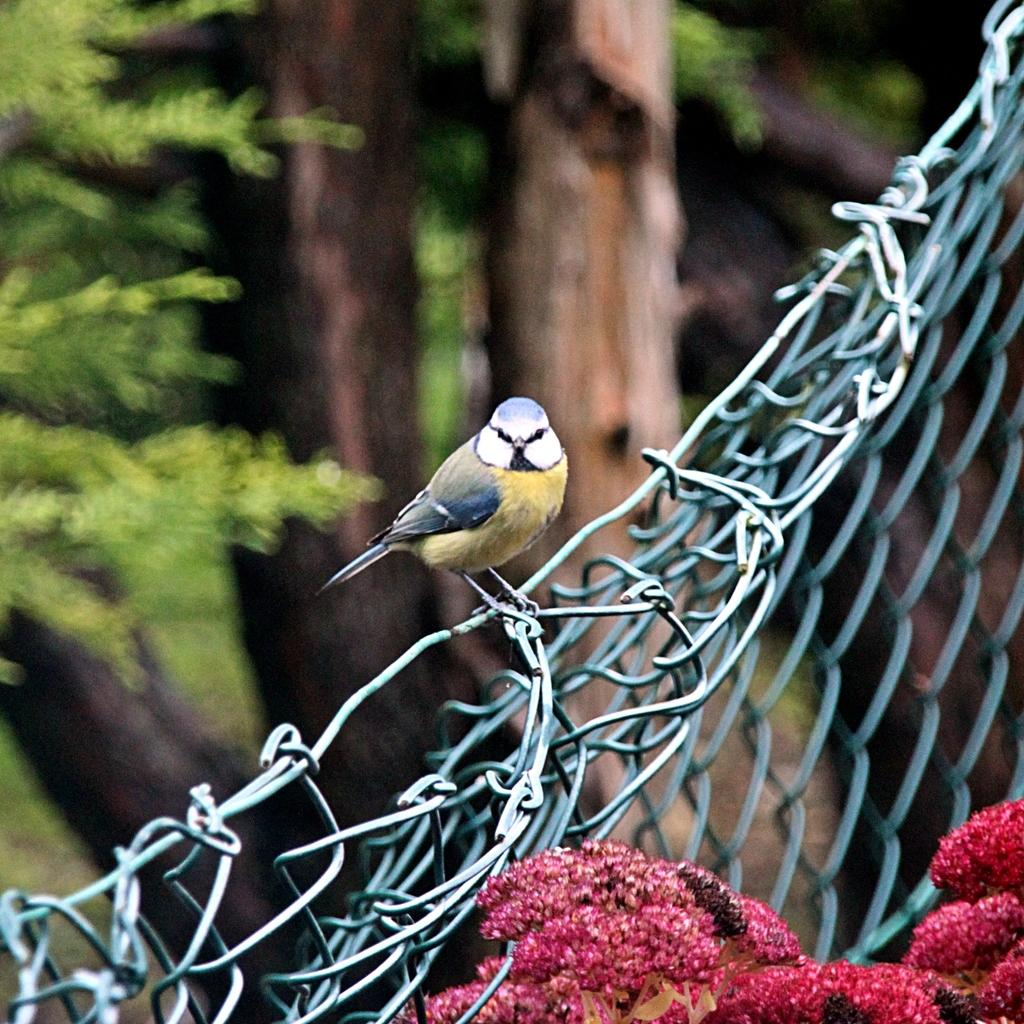What type of vegetation can be seen at the bottom right side of the image? There are flowers at the bottom right side of the image. What is located in the center of the image? There is a mesh in the center of the image. What animal is perched on the mesh? A bird is present on the mesh. What can be seen in the distance in the image? There are trees visible in the background of the image. How many tomatoes are hanging from the mesh in the image? There are no tomatoes present in the image; it features a bird on a mesh. What type of fowl is shown interacting with the mesh in the image? There is no fowl shown interacting with the mesh in the image; only a bird is present. 